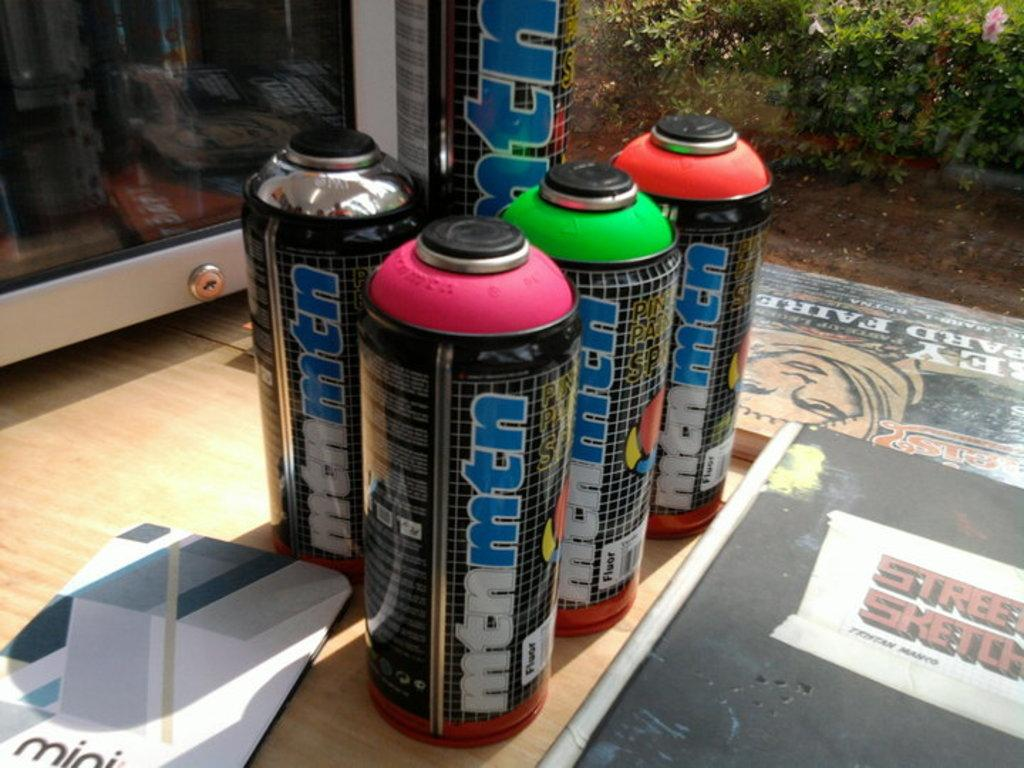<image>
Render a clear and concise summary of the photo. Different colored bottles that say "mtmmtm" on their side are sitting on a wooden table. 